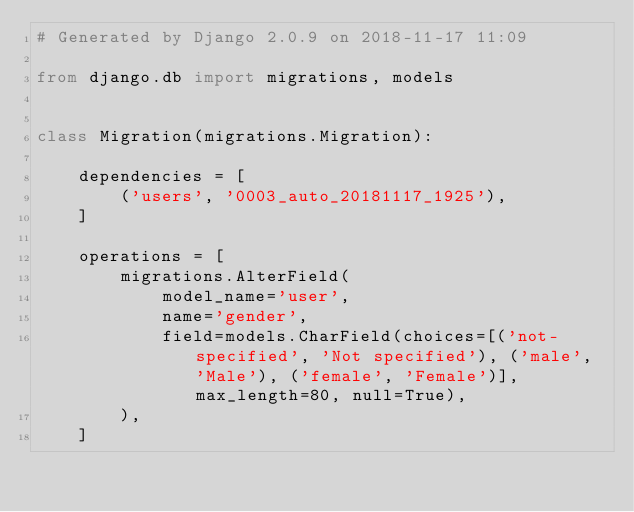<code> <loc_0><loc_0><loc_500><loc_500><_Python_># Generated by Django 2.0.9 on 2018-11-17 11:09

from django.db import migrations, models


class Migration(migrations.Migration):

    dependencies = [
        ('users', '0003_auto_20181117_1925'),
    ]

    operations = [
        migrations.AlterField(
            model_name='user',
            name='gender',
            field=models.CharField(choices=[('not-specified', 'Not specified'), ('male', 'Male'), ('female', 'Female')], max_length=80, null=True),
        ),
    ]
</code> 